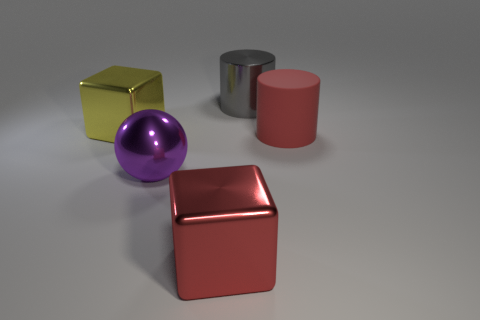There is a large yellow metallic block; what number of purple spheres are behind it?
Offer a very short reply. 0. What number of things are shiny cubes that are in front of the large metallic ball or green metallic objects?
Provide a succinct answer. 1. Is the number of big cylinders on the right side of the gray cylinder greater than the number of large red rubber cylinders that are left of the large purple sphere?
Your answer should be compact. Yes. What size is the metal cube that is the same color as the rubber object?
Offer a terse response. Large. Is the size of the gray cylinder the same as the red object that is in front of the purple object?
Provide a short and direct response. Yes. What number of cubes are either big shiny objects or red metallic things?
Your answer should be very brief. 2. What size is the red object that is made of the same material as the large gray object?
Your response must be concise. Large. How many things are large green metallic things or big metal balls?
Your answer should be very brief. 1. What is the shape of the gray thing?
Keep it short and to the point. Cylinder. Are there any other things that are made of the same material as the large red cylinder?
Your answer should be compact. No. 